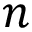<formula> <loc_0><loc_0><loc_500><loc_500>n</formula> 